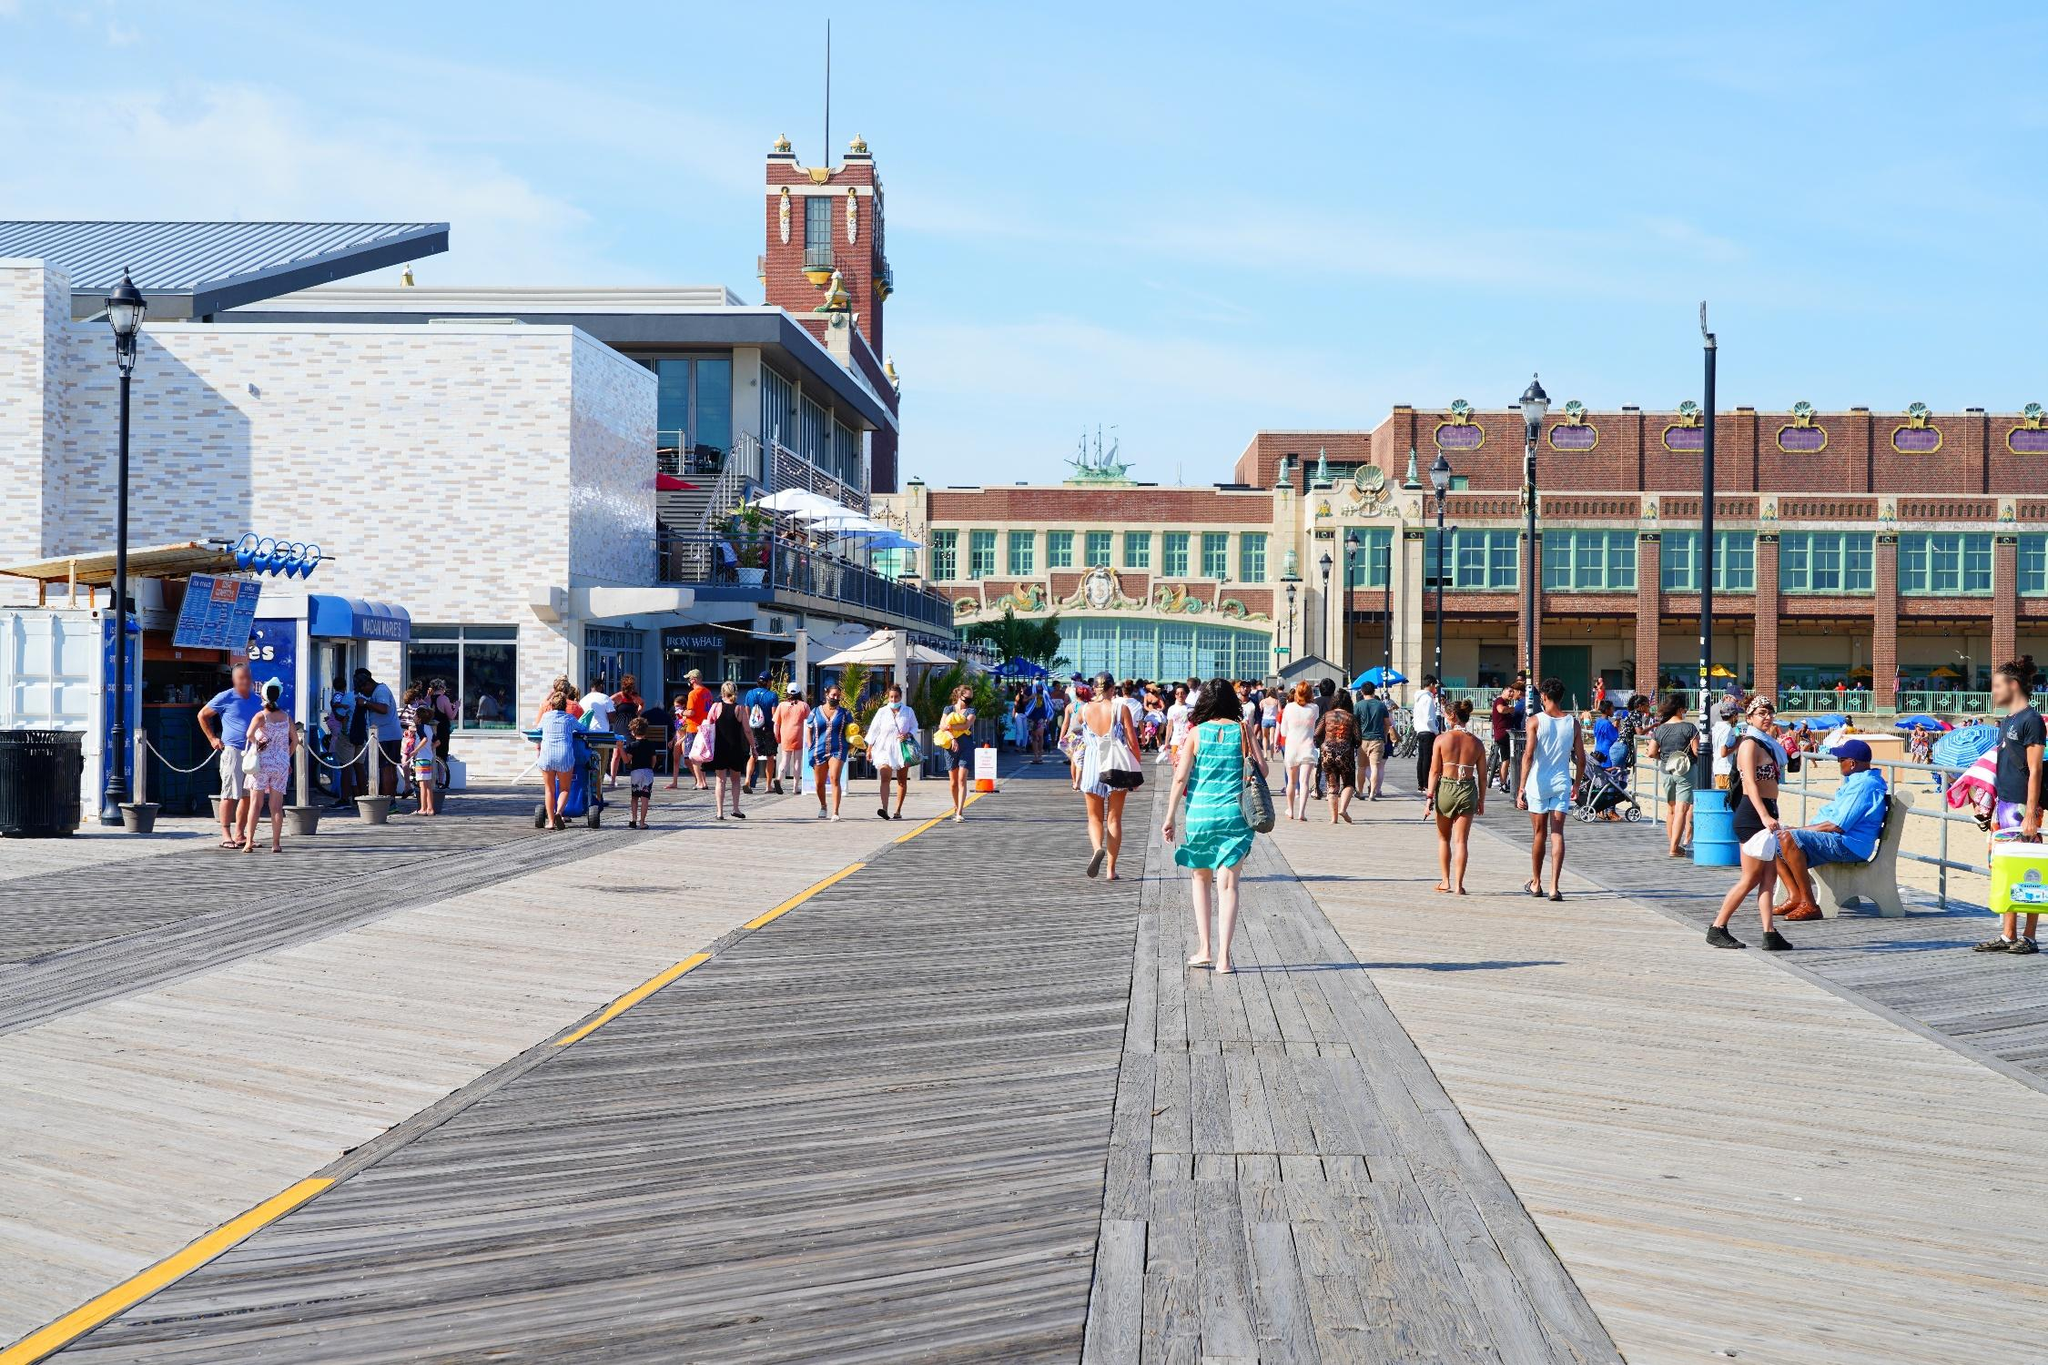What can you tell me about the architectural styles present in this image? The architectural styles in the image blend modern and historic elements, creating a rich tapestry of design. On the left, the white building with clean lines and minimal ornamentation showcases modern architectural aesthetics. In contrast, the building in the background with the tall brick clock tower exhibits a more historic and ornate style, likely influenced by early 20th-century architecture. The detailed window designs and decorative elements on the facades add a touch of elegance and nostalgia, reflecting a time when craftsmanship was paramount. This mix of styles not only highlights the area's evolution over time but also enhances its charm and appeal. How does the atmosphere in the image impact your feelings? Why? The atmosphere of the image evokes a sense of relaxation and joy. The bright, sunny day coupled with the clear blue sky fosters feelings of warmth and happiness. The presence of happy and engaged people contributes to a lively and inviting ambiance. The orderly arrangement of shops and restaurants, along with the clean, well-maintained boardwalk, provides a sense of safety and enjoyment. This combination of elements makes one feel uplifted and eager to join in the leisurely activities depicted. If you were to create a historical story set in this place, what would it be about? In the early 1920s, Asbury Park was a flourishing seaside destination drawing visitors from far and wide. A young woman named Evelyn moved to Asbury Park in hopes of starting a new chapter in her life. She opened a quaint shop on the boardwalk that sold handcrafted seashell jewelry, quickly becoming a beloved figure in the community. One day, a mysterious traveler named Henry stumbled into her shop. A World War I veteran, Henry carried with him a worn-out, antique compass said to hold the secrets of a lost treasure hidden beneath the boardwalk. Evelyn and Henry formed an unlikely partnership, embarking on a fascinating adventure to unearth the treasure. Their journey was filled with historical relics, old maps, and encounters with various townsfolk who kept the legends of the treasure alive. Ultimately, their tale brought the community even closer, ensuring that the rich history and vibrant traditions of Asbury Park would be cherished for generations to come. 